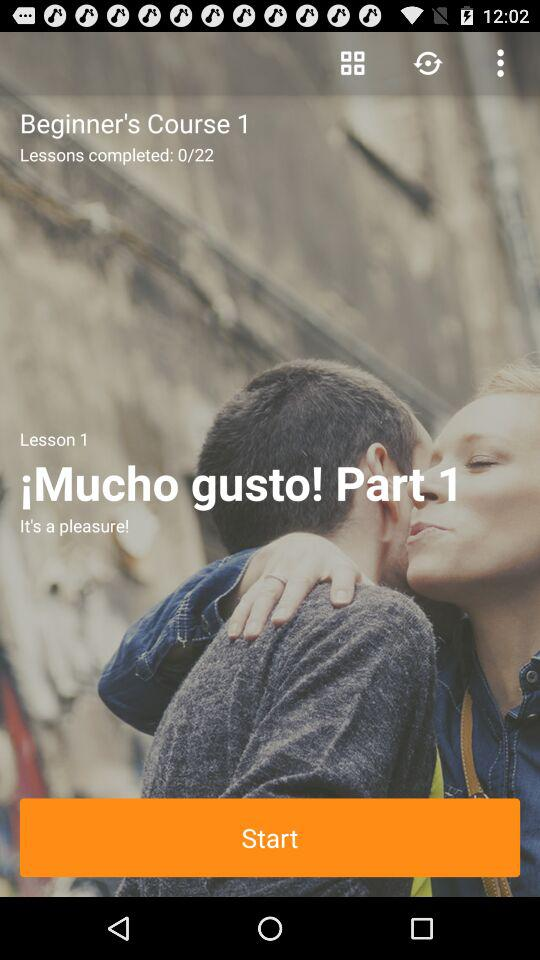Which lesson is the person currently on? The person is currently on lesson 1. 